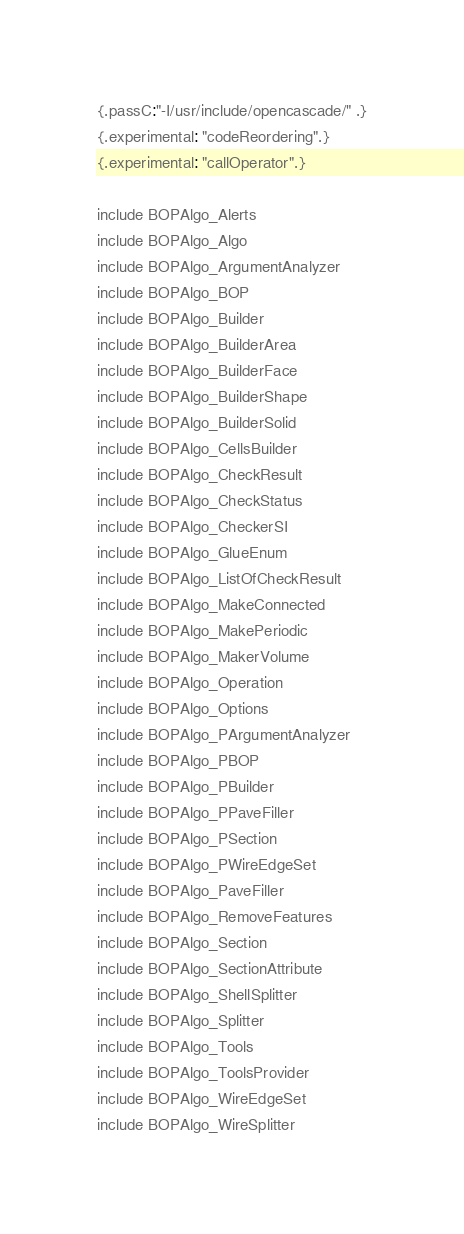Convert code to text. <code><loc_0><loc_0><loc_500><loc_500><_Nim_>{.passC:"-I/usr/include/opencascade/" .}
{.experimental: "codeReordering".}
{.experimental: "callOperator".}

include BOPAlgo_Alerts
include BOPAlgo_Algo
include BOPAlgo_ArgumentAnalyzer
include BOPAlgo_BOP
include BOPAlgo_Builder
include BOPAlgo_BuilderArea
include BOPAlgo_BuilderFace
include BOPAlgo_BuilderShape
include BOPAlgo_BuilderSolid
include BOPAlgo_CellsBuilder
include BOPAlgo_CheckResult
include BOPAlgo_CheckStatus
include BOPAlgo_CheckerSI
include BOPAlgo_GlueEnum
include BOPAlgo_ListOfCheckResult
include BOPAlgo_MakeConnected
include BOPAlgo_MakePeriodic
include BOPAlgo_MakerVolume
include BOPAlgo_Operation
include BOPAlgo_Options
include BOPAlgo_PArgumentAnalyzer
include BOPAlgo_PBOP
include BOPAlgo_PBuilder
include BOPAlgo_PPaveFiller
include BOPAlgo_PSection
include BOPAlgo_PWireEdgeSet
include BOPAlgo_PaveFiller
include BOPAlgo_RemoveFeatures
include BOPAlgo_Section
include BOPAlgo_SectionAttribute
include BOPAlgo_ShellSplitter
include BOPAlgo_Splitter
include BOPAlgo_Tools
include BOPAlgo_ToolsProvider
include BOPAlgo_WireEdgeSet
include BOPAlgo_WireSplitter


























</code> 